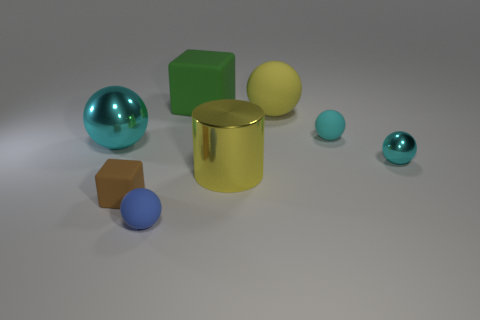How many cyan spheres must be subtracted to get 2 cyan spheres? 1 Subtract all brown cylinders. How many cyan balls are left? 3 Subtract all yellow spheres. How many spheres are left? 4 Add 1 small gray shiny things. How many objects exist? 9 Subtract all green spheres. Subtract all brown cylinders. How many spheres are left? 5 Subtract all cubes. How many objects are left? 6 Subtract all small cyan objects. Subtract all small blocks. How many objects are left? 5 Add 2 tiny brown rubber things. How many tiny brown rubber things are left? 3 Add 8 big yellow shiny cylinders. How many big yellow shiny cylinders exist? 9 Subtract 0 gray cubes. How many objects are left? 8 